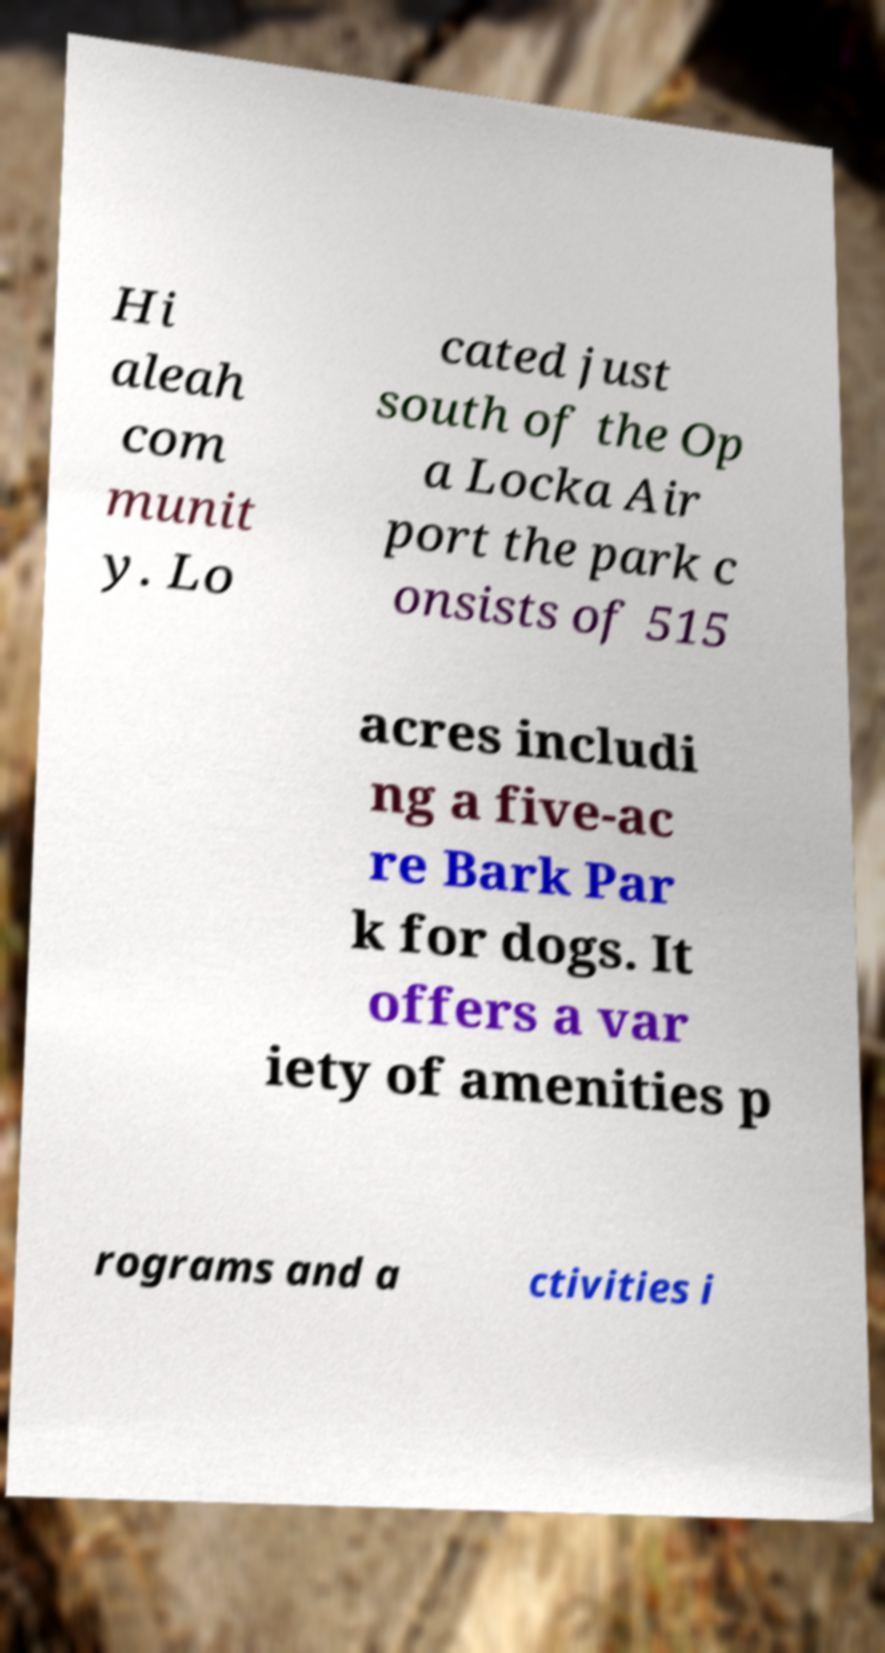Can you accurately transcribe the text from the provided image for me? Hi aleah com munit y. Lo cated just south of the Op a Locka Air port the park c onsists of 515 acres includi ng a five-ac re Bark Par k for dogs. It offers a var iety of amenities p rograms and a ctivities i 